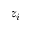Convert formula to latex. <formula><loc_0><loc_0><loc_500><loc_500>z _ { i }</formula> 